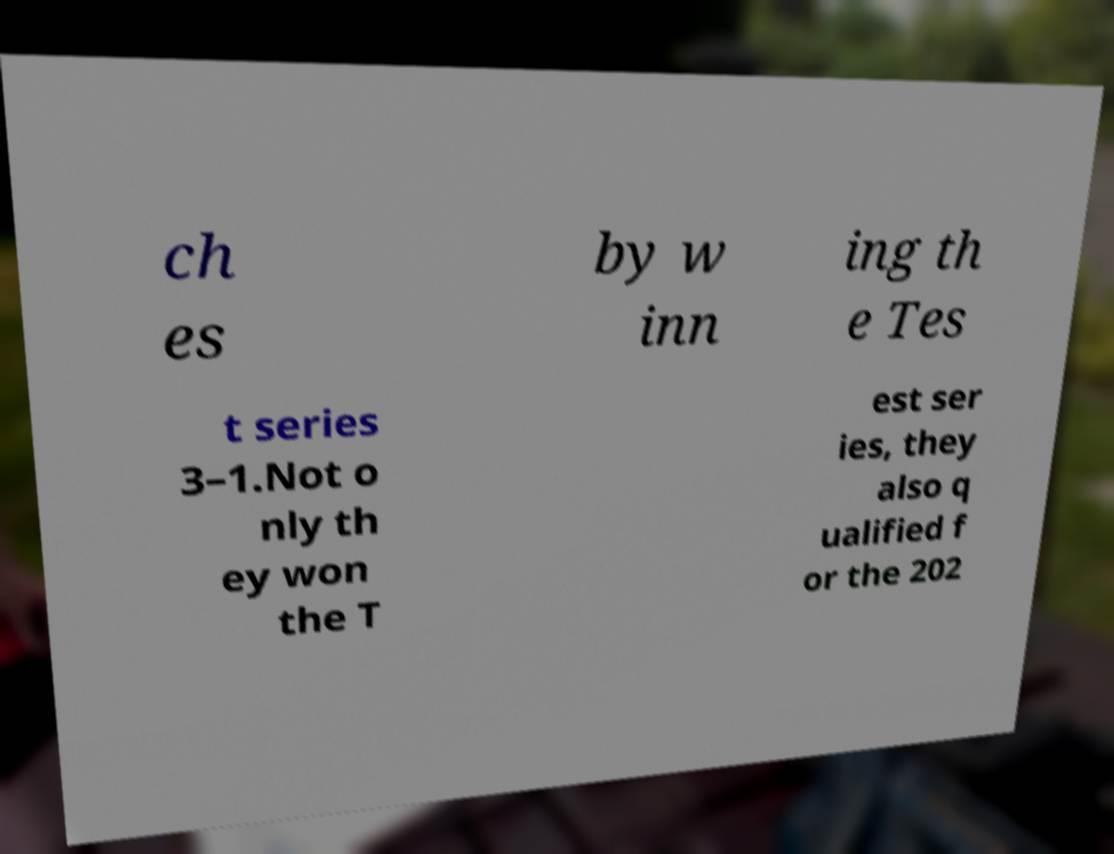Please identify and transcribe the text found in this image. ch es by w inn ing th e Tes t series 3–1.Not o nly th ey won the T est ser ies, they also q ualified f or the 202 